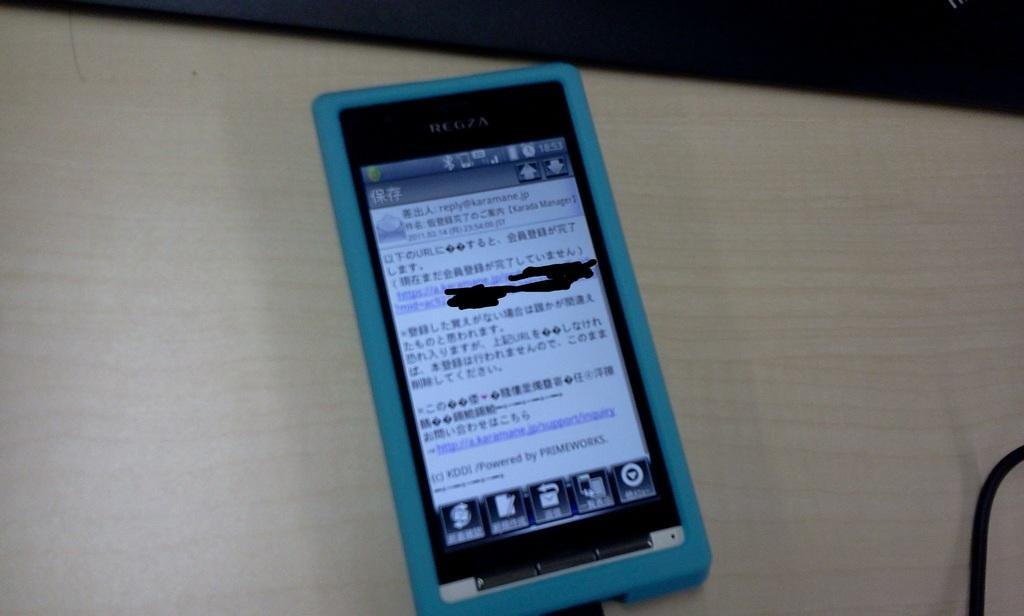Provide a one-sentence caption for the provided image. a smartphone with a blue case open to an email from reply@karamane.jp. 